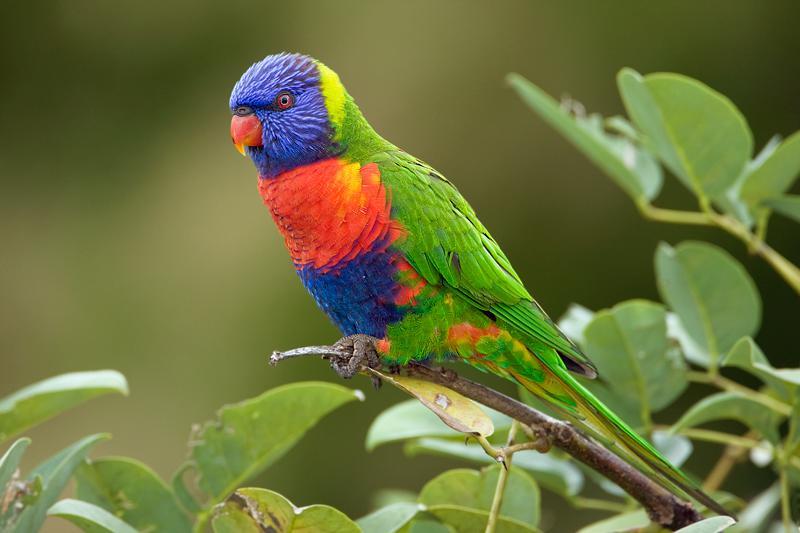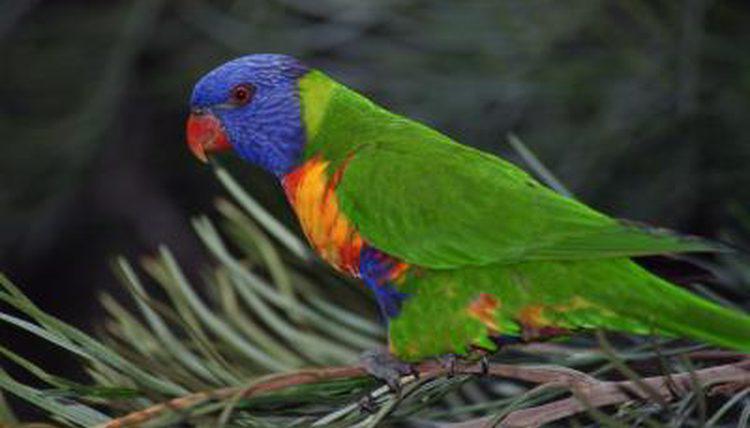The first image is the image on the left, the second image is the image on the right. Considering the images on both sides, is "There are three birds" valid? Answer yes or no. No. 